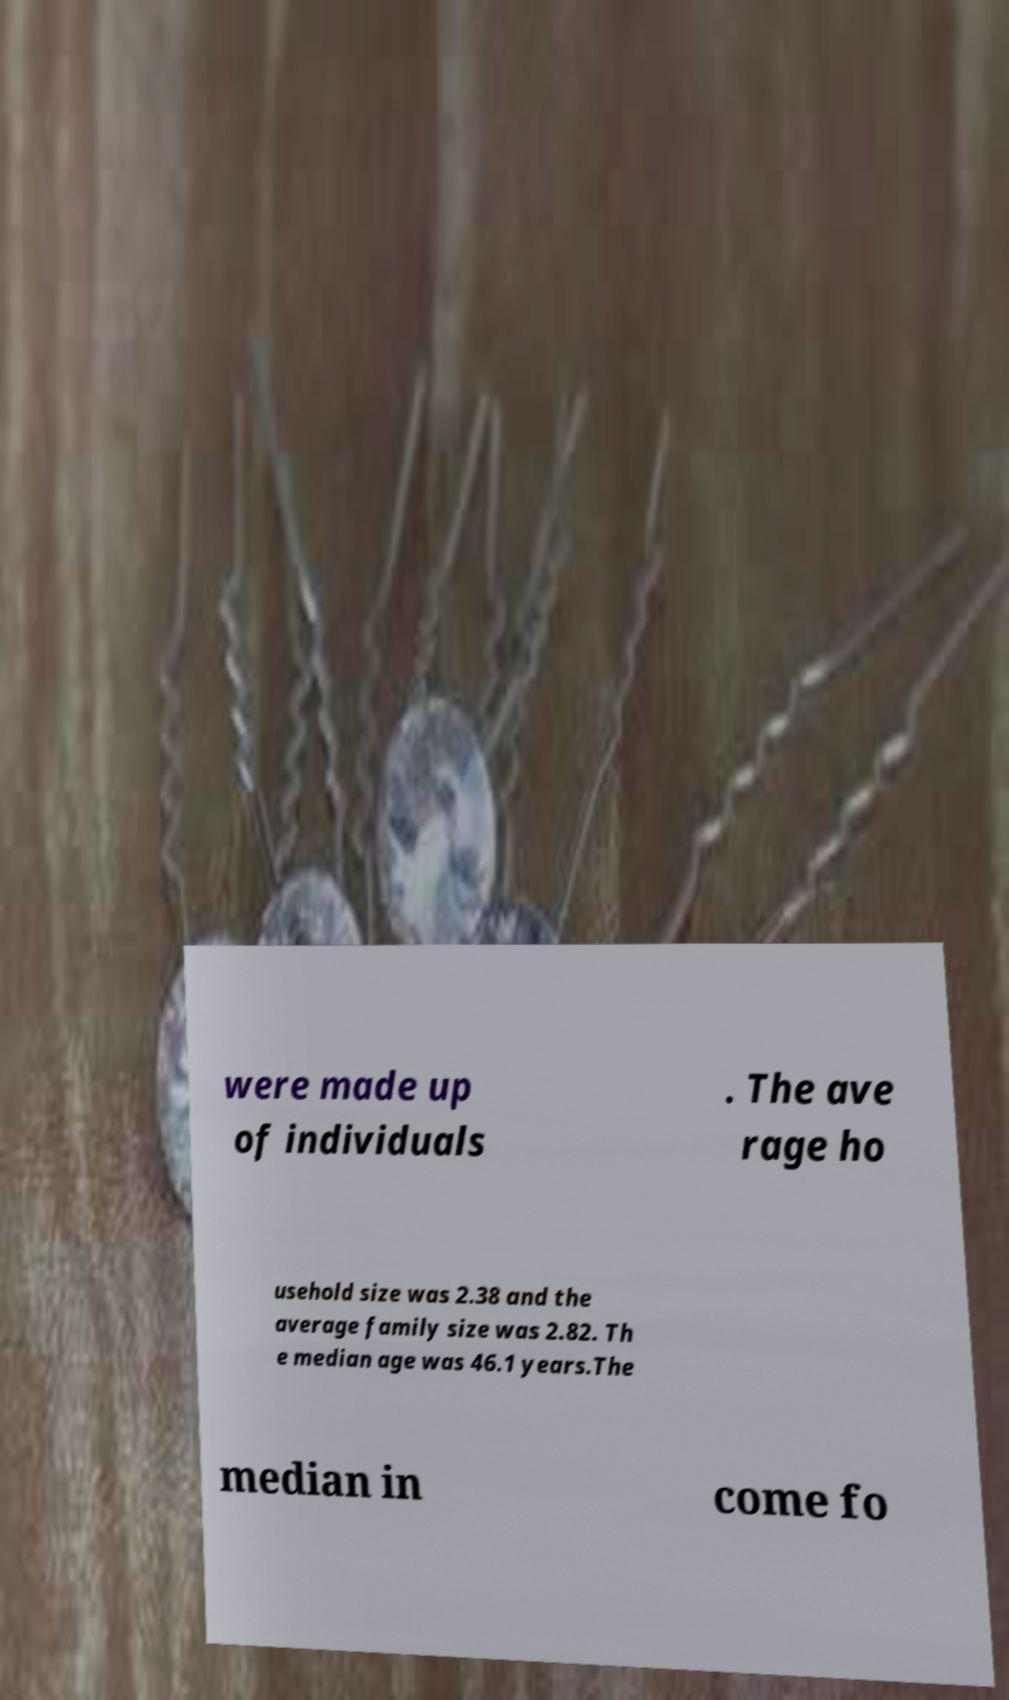Please read and relay the text visible in this image. What does it say? were made up of individuals . The ave rage ho usehold size was 2.38 and the average family size was 2.82. Th e median age was 46.1 years.The median in come fo 